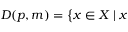Convert formula to latex. <formula><loc_0><loc_0><loc_500><loc_500>D ( p , m ) = { \Big \{ } x \in X | x</formula> 